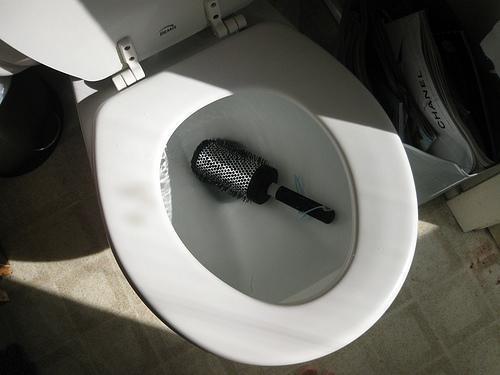How many pieces of broccoli are in the dish?
Give a very brief answer. 0. 